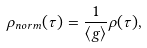Convert formula to latex. <formula><loc_0><loc_0><loc_500><loc_500>\rho _ { n o r m } ( \tau ) = \frac { 1 } { \left < g \right > } \rho ( \tau ) ,</formula> 